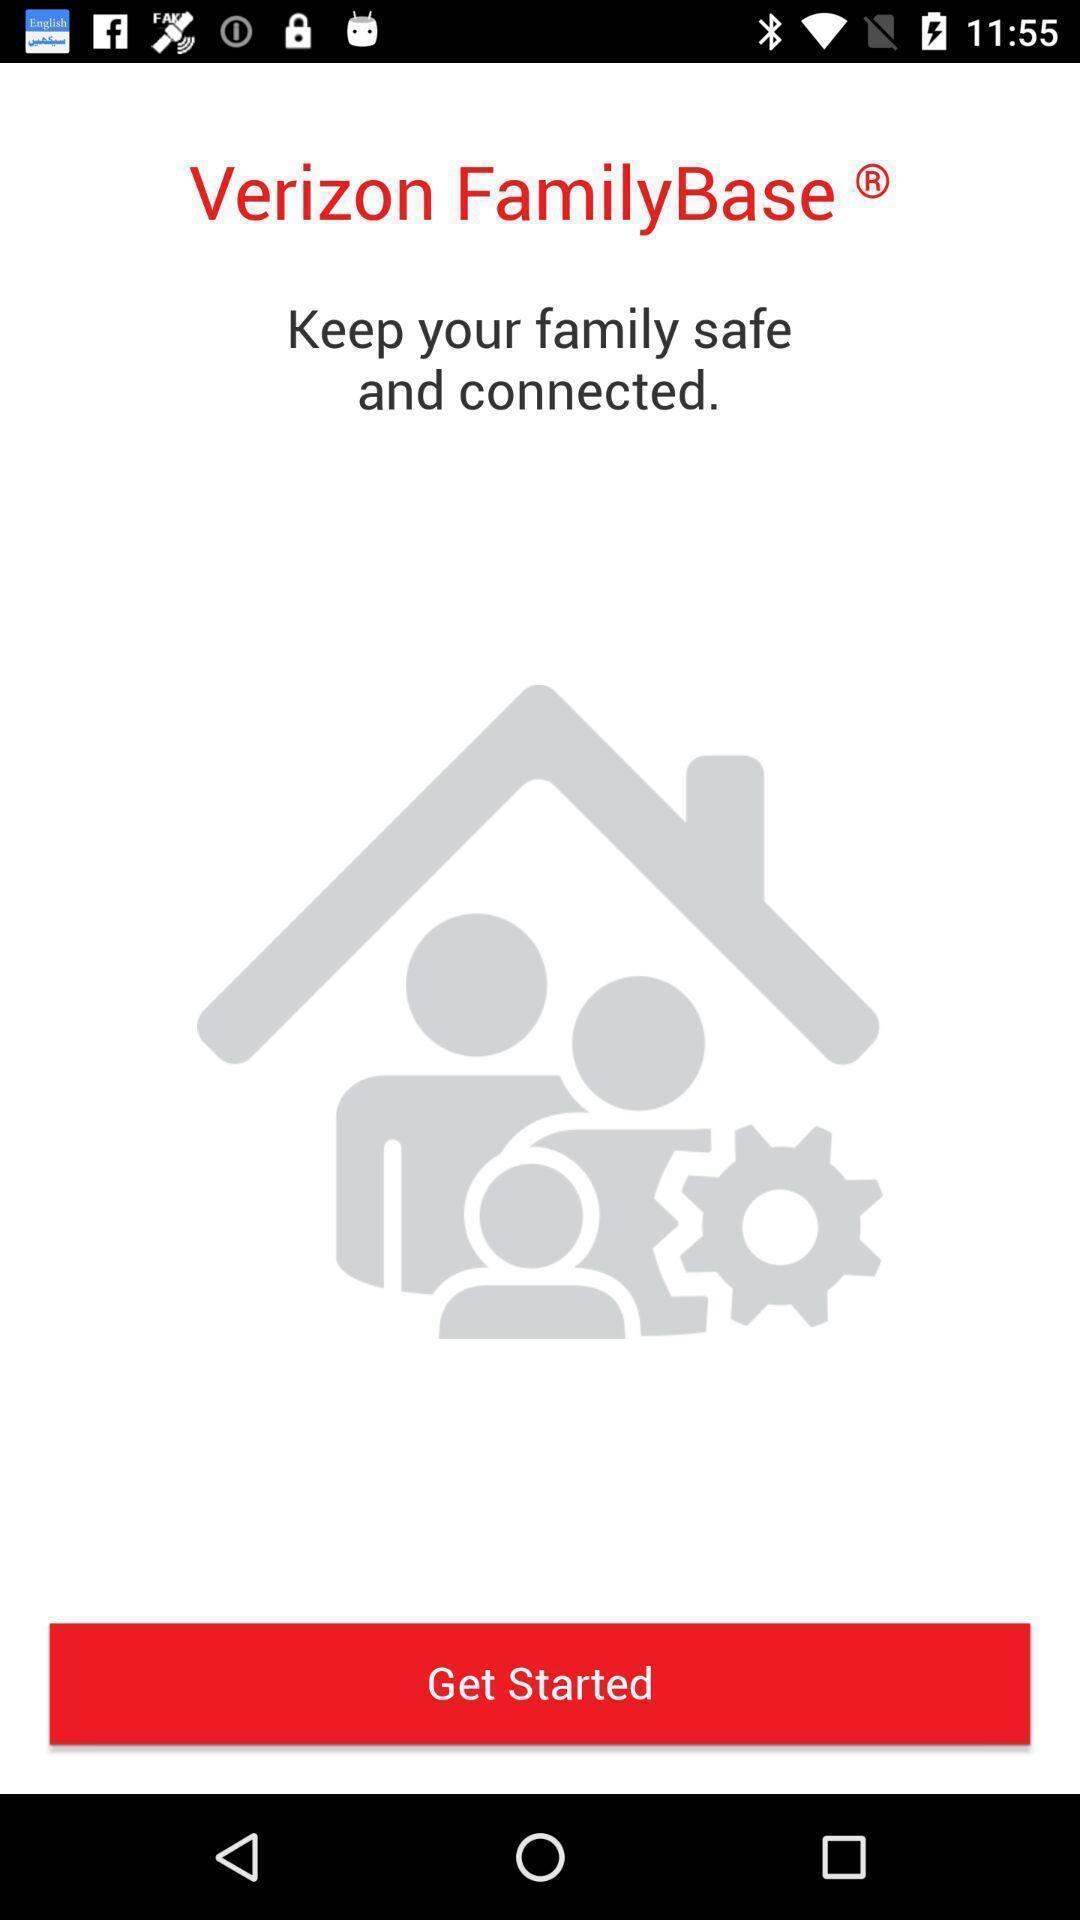Tell me what you see in this picture. Welcome page. 